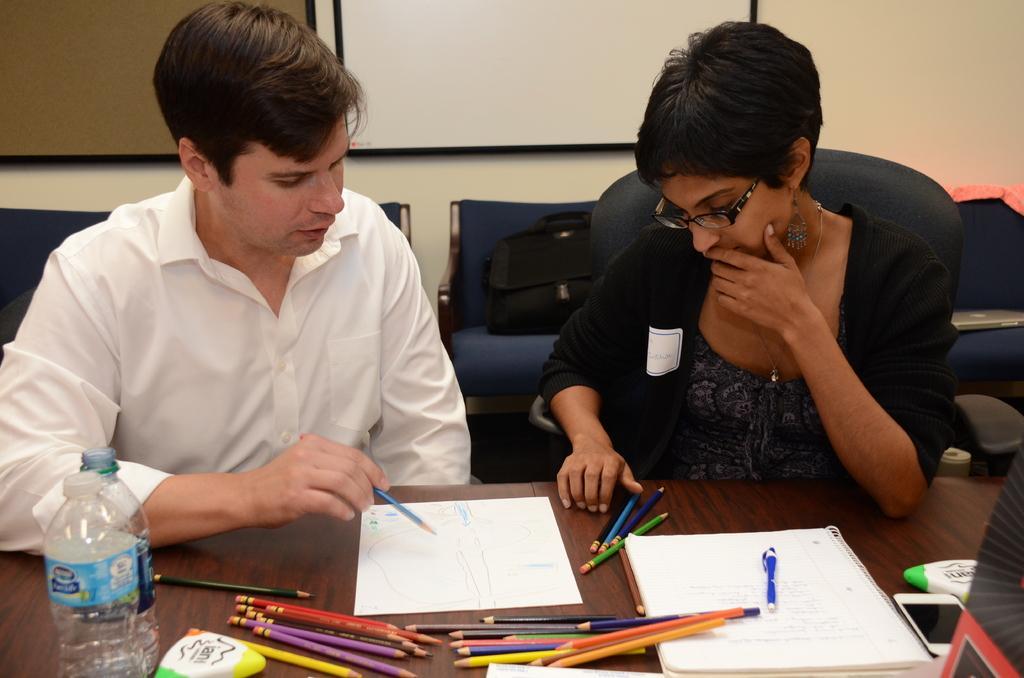How would you summarize this image in a sentence or two? This 2 persons are highlighted in this picture. This 2 persons are sitting on a chair. Background there is a whiteboard. This is a couch. On a couch there is a bag. In-front of this 2 persons there is a table. On a table there is a paper, color pencils and a bottle. This man holds pencil. This woman wore spectacles and black jacket. On a table there is a mobile. 